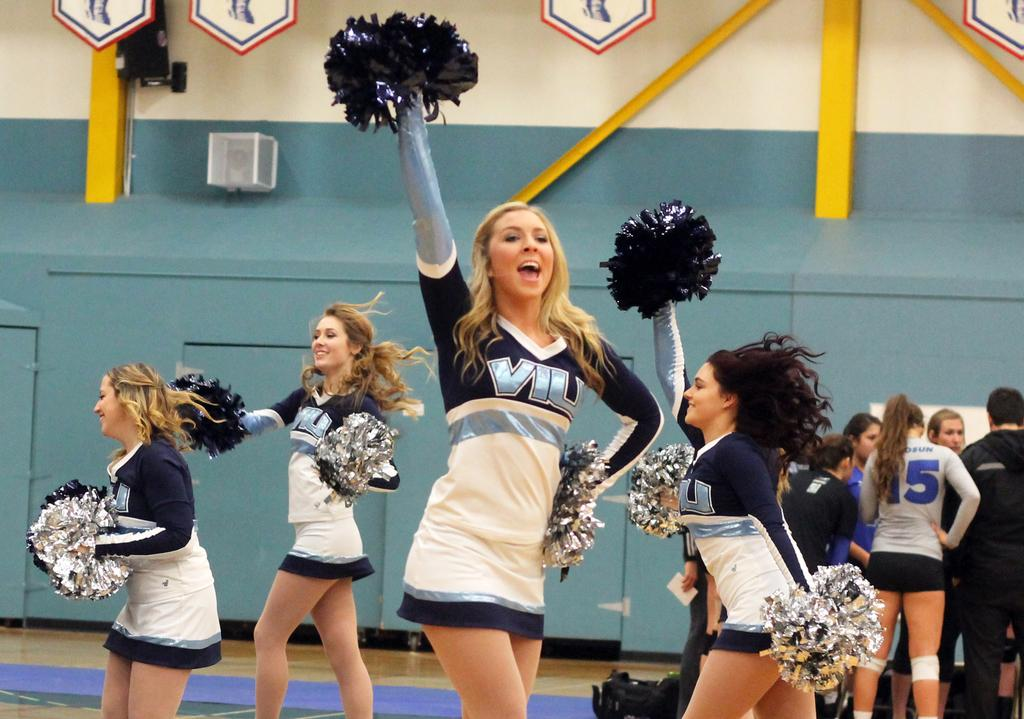Provide a one-sentence caption for the provided image. Cheerleaders wear uniforms with the initials "VIU" on the front. 